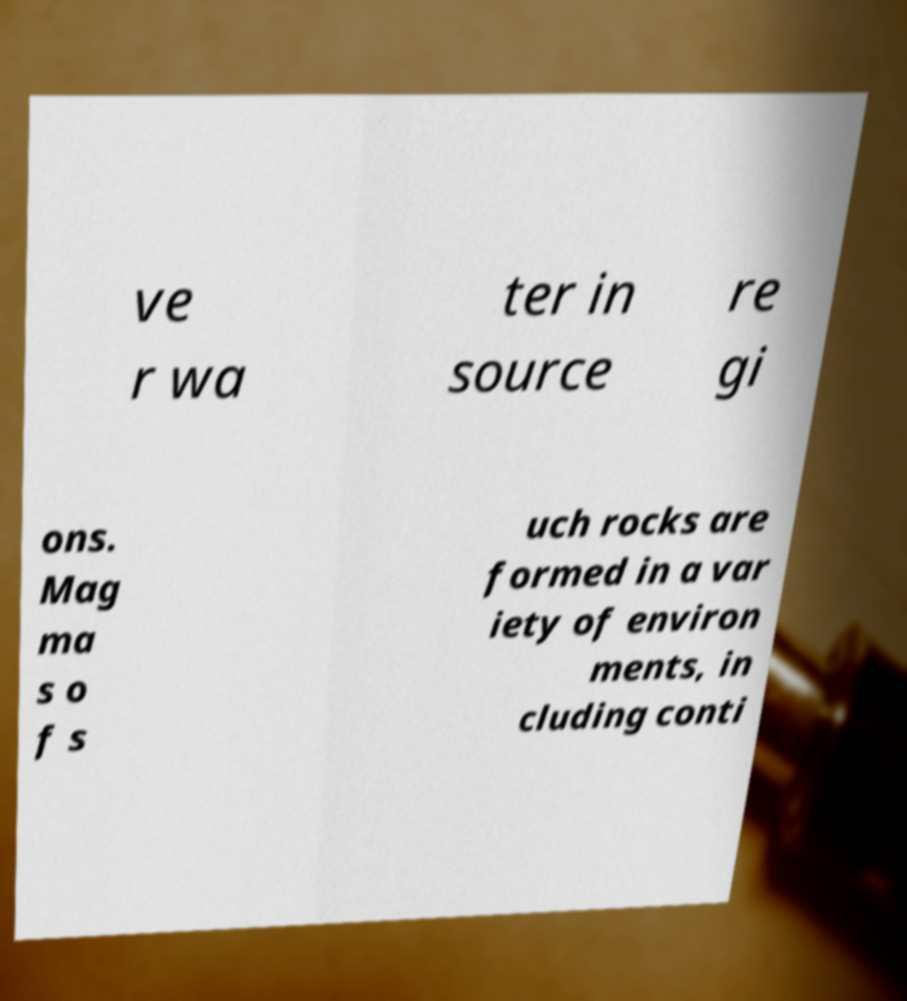Could you extract and type out the text from this image? ve r wa ter in source re gi ons. Mag ma s o f s uch rocks are formed in a var iety of environ ments, in cluding conti 